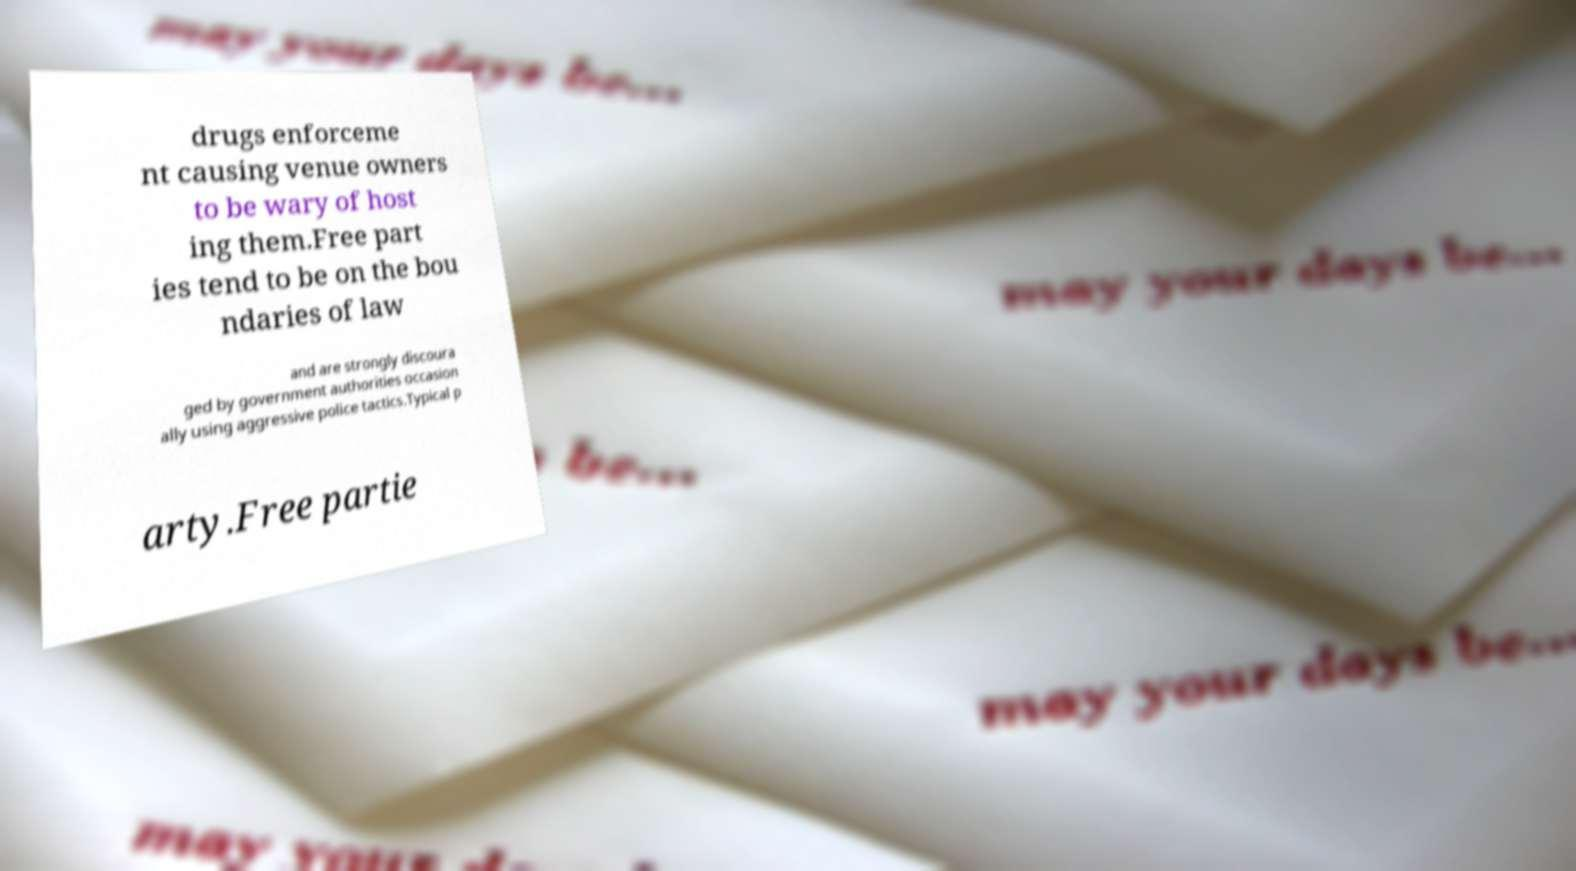Please read and relay the text visible in this image. What does it say? drugs enforceme nt causing venue owners to be wary of host ing them.Free part ies tend to be on the bou ndaries of law and are strongly discoura ged by government authorities occasion ally using aggressive police tactics.Typical p arty.Free partie 